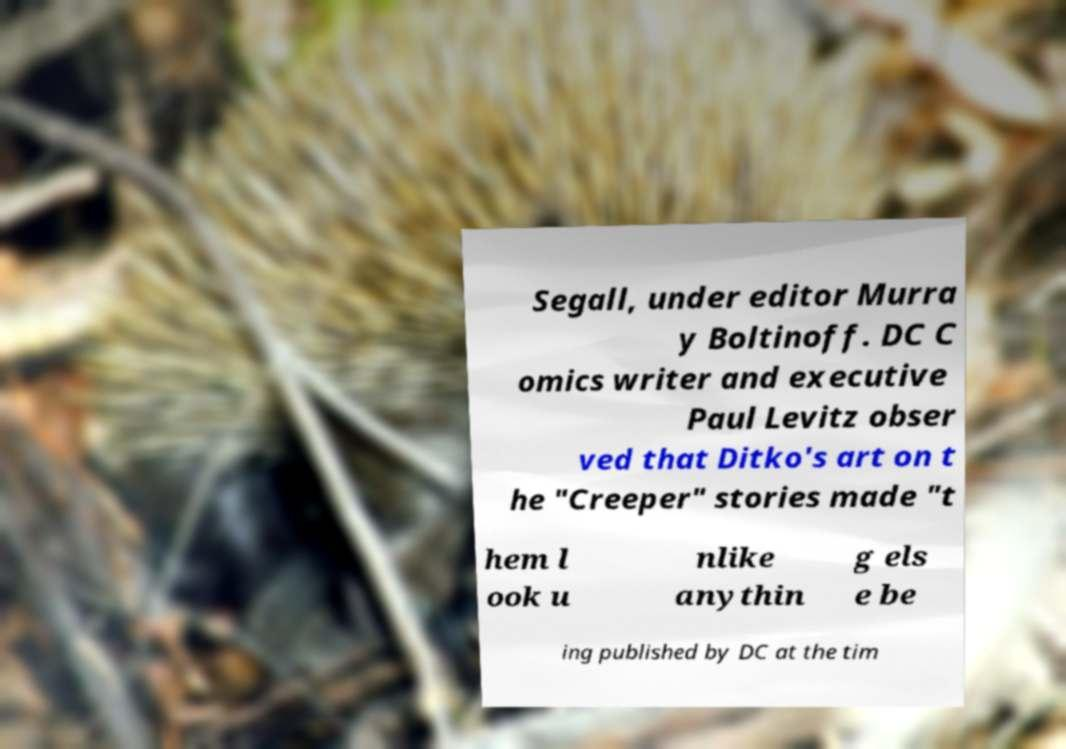Could you extract and type out the text from this image? Segall, under editor Murra y Boltinoff. DC C omics writer and executive Paul Levitz obser ved that Ditko's art on t he "Creeper" stories made "t hem l ook u nlike anythin g els e be ing published by DC at the tim 